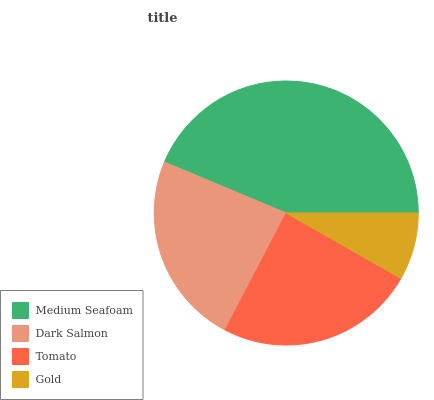Is Gold the minimum?
Answer yes or no. Yes. Is Medium Seafoam the maximum?
Answer yes or no. Yes. Is Dark Salmon the minimum?
Answer yes or no. No. Is Dark Salmon the maximum?
Answer yes or no. No. Is Medium Seafoam greater than Dark Salmon?
Answer yes or no. Yes. Is Dark Salmon less than Medium Seafoam?
Answer yes or no. Yes. Is Dark Salmon greater than Medium Seafoam?
Answer yes or no. No. Is Medium Seafoam less than Dark Salmon?
Answer yes or no. No. Is Tomato the high median?
Answer yes or no. Yes. Is Dark Salmon the low median?
Answer yes or no. Yes. Is Gold the high median?
Answer yes or no. No. Is Medium Seafoam the low median?
Answer yes or no. No. 